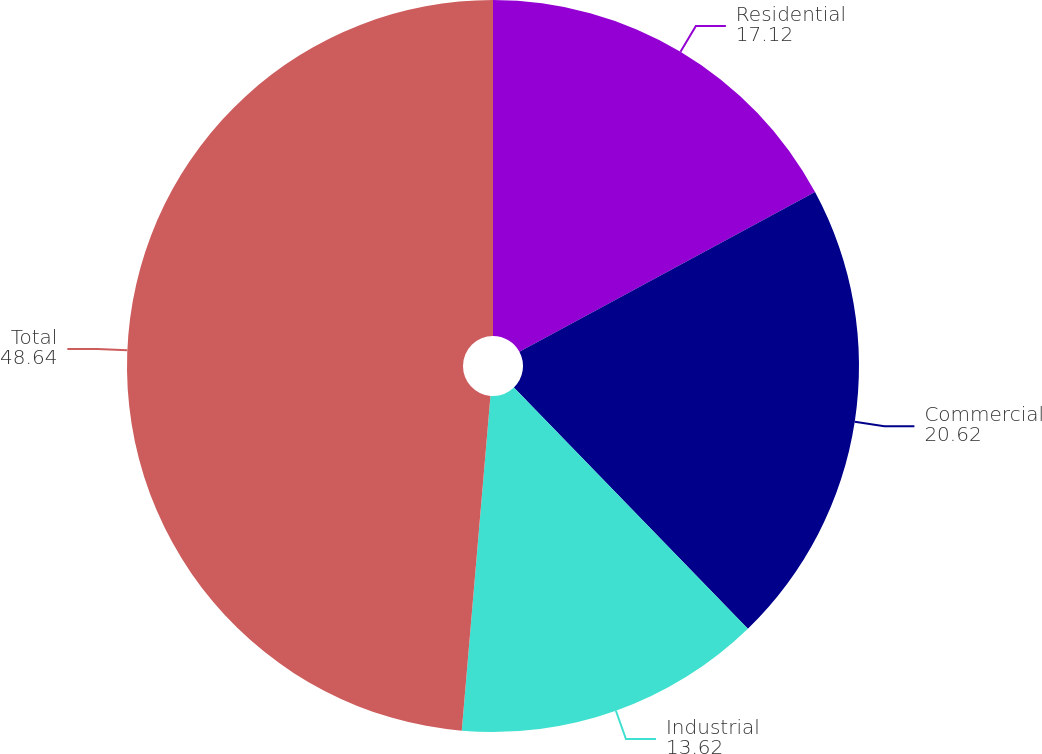Convert chart to OTSL. <chart><loc_0><loc_0><loc_500><loc_500><pie_chart><fcel>Residential<fcel>Commercial<fcel>Industrial<fcel>Total<nl><fcel>17.12%<fcel>20.62%<fcel>13.62%<fcel>48.64%<nl></chart> 